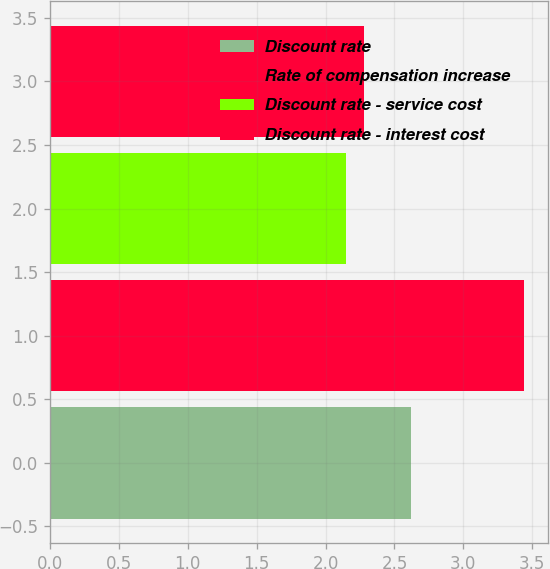<chart> <loc_0><loc_0><loc_500><loc_500><bar_chart><fcel>Discount rate<fcel>Rate of compensation increase<fcel>Discount rate - service cost<fcel>Discount rate - interest cost<nl><fcel>2.62<fcel>3.44<fcel>2.15<fcel>2.28<nl></chart> 